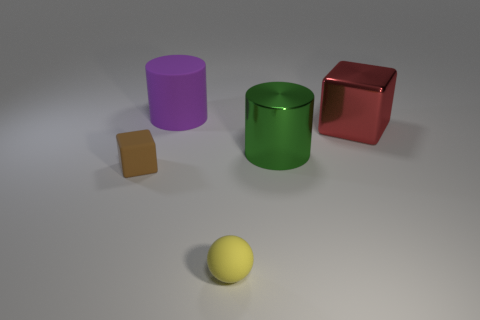What number of objects are either tiny things or tiny brown rubber things?
Keep it short and to the point. 2. What number of other objects are there of the same size as the green shiny object?
Make the answer very short. 2. What number of rubber objects are both in front of the big green cylinder and behind the tiny brown object?
Your answer should be very brief. 0. There is a cylinder behind the large red cube; does it have the same size as the cylinder right of the small yellow object?
Provide a short and direct response. Yes. There is a brown thing that is left of the tiny yellow ball; how big is it?
Your response must be concise. Small. What number of things are either metal blocks that are in front of the rubber cylinder or rubber objects that are right of the tiny brown cube?
Your answer should be very brief. 3. Are there any other things that are the same color as the small rubber sphere?
Offer a terse response. No. Are there an equal number of red shiny things that are in front of the big cube and big green shiny cylinders that are to the left of the green shiny object?
Your response must be concise. Yes. Is the number of red metallic blocks that are in front of the brown thing greater than the number of brown things?
Your answer should be very brief. No. How many objects are cylinders that are on the right side of the yellow rubber object or purple rubber things?
Provide a short and direct response. 2. 